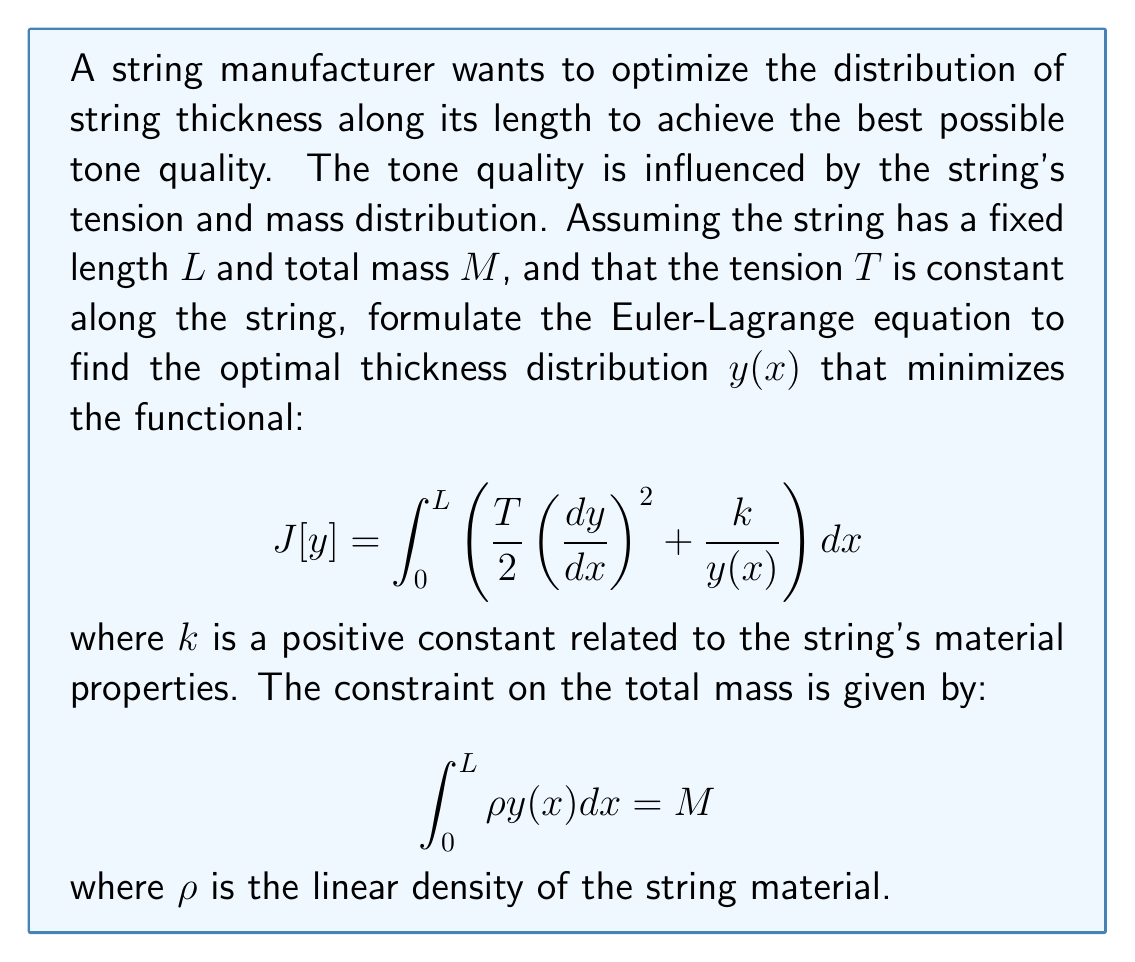Could you help me with this problem? To solve this problem, we need to use the calculus of variations and the Euler-Lagrange equation with a constraint. Let's approach this step-by-step:

1) First, we need to form the augmented functional by incorporating the constraint using a Lagrange multiplier $\lambda$:

   $$J_a[y] = \int_0^L \left[\frac{T}{2}\left(\frac{dy}{dx}\right)^2 + \frac{k}{y(x)} + \lambda(\rho y(x) - \frac{M}{L})\right] dx$$

2) The Euler-Lagrange equation for this problem is:

   $$\frac{\partial F}{\partial y} - \frac{d}{dx}\left(\frac{\partial F}{\partial y'}\right) = 0$$

   where $F$ is the integrand of our augmented functional.

3) Let's calculate the partial derivatives:

   $$\frac{\partial F}{\partial y} = -\frac{k}{y^2} + \lambda\rho$$
   
   $$\frac{\partial F}{\partial y'} = Ty'$$

4) Substituting these into the Euler-Lagrange equation:

   $$-\frac{k}{y^2} + \lambda\rho - \frac{d}{dx}(Ty') = 0$$

5) Since $T$ is constant, we can simplify:

   $$-\frac{k}{y^2} + \lambda\rho - Ty'' = 0$$

6) Rearranging terms:

   $$Ty'' = -\frac{k}{y^2} + \lambda\rho$$

This is the Euler-Lagrange equation for our problem. It's a second-order nonlinear differential equation that describes the optimal thickness distribution $y(x)$ along the string.

To fully solve this problem, we would need to specify boundary conditions and solve the differential equation, which is beyond the scope of this question. However, this equation provides valuable insights into the optimal thickness distribution:

- The term $-\frac{k}{y^2}$ suggests that the thickness tends to increase where it's currently small.
- The constant term $\lambda\rho$ represents the effect of the mass constraint.
- The $Ty''$ term relates to the curvature of the thickness distribution.
Answer: The Euler-Lagrange equation for the optimal thickness distribution $y(x)$ is:

$$Ty'' = -\frac{k}{y^2} + \lambda\rho$$

where $T$ is the string tension, $k$ is the material constant, $\rho$ is the linear density, and $\lambda$ is the Lagrange multiplier for the mass constraint. 